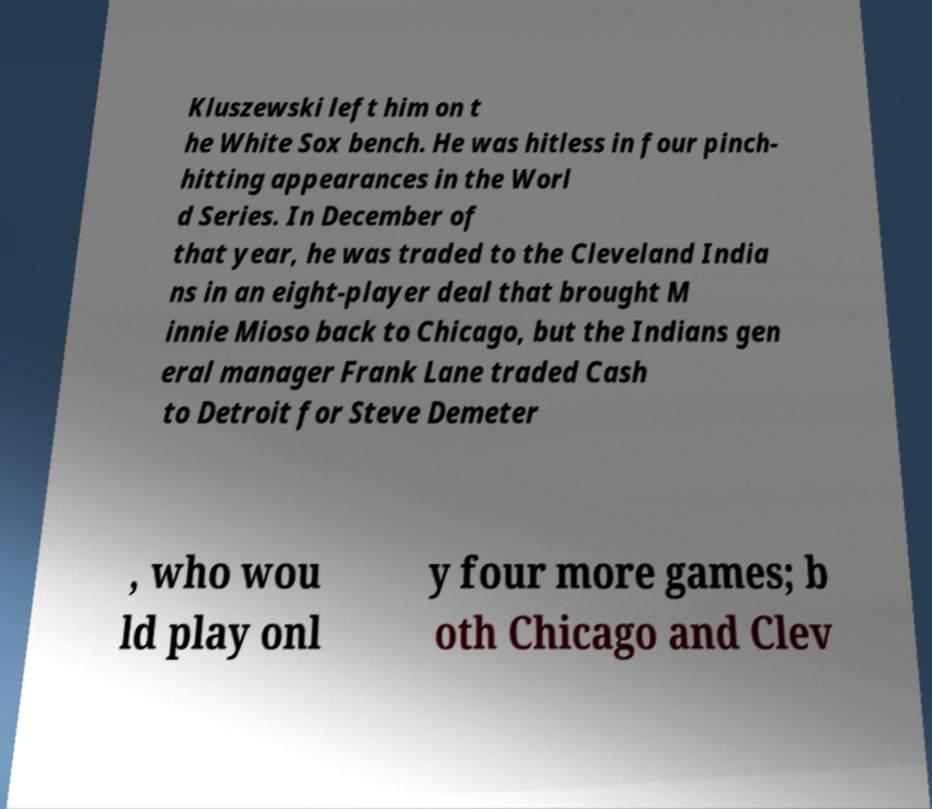There's text embedded in this image that I need extracted. Can you transcribe it verbatim? Kluszewski left him on t he White Sox bench. He was hitless in four pinch- hitting appearances in the Worl d Series. In December of that year, he was traded to the Cleveland India ns in an eight-player deal that brought M innie Mioso back to Chicago, but the Indians gen eral manager Frank Lane traded Cash to Detroit for Steve Demeter , who wou ld play onl y four more games; b oth Chicago and Clev 